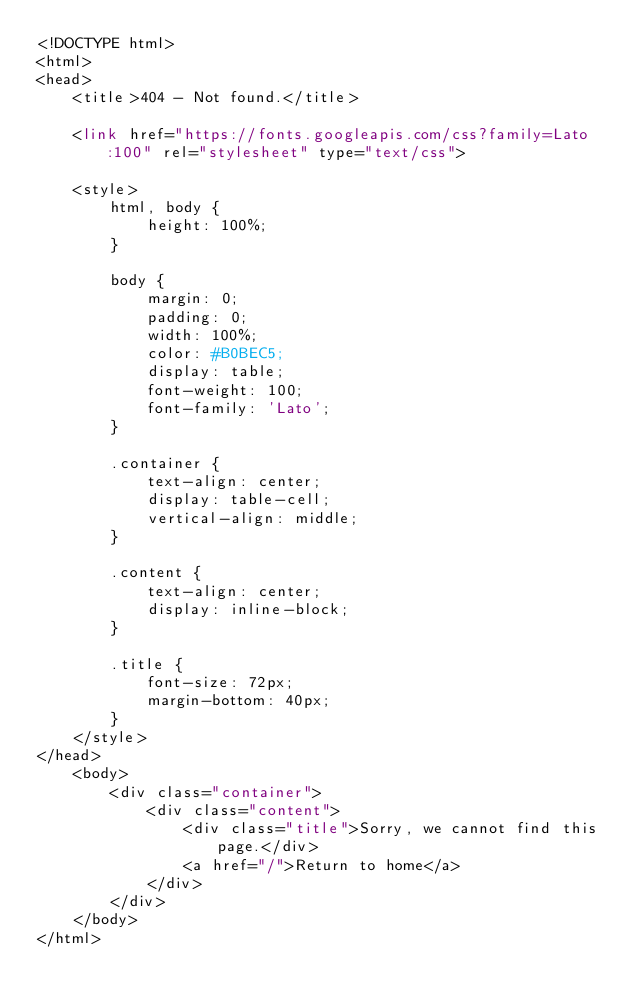Convert code to text. <code><loc_0><loc_0><loc_500><loc_500><_PHP_><!DOCTYPE html>
<html>
<head>
    <title>404 - Not found.</title>

    <link href="https://fonts.googleapis.com/css?family=Lato:100" rel="stylesheet" type="text/css">

    <style>
        html, body {
            height: 100%;
        }

        body {
            margin: 0;
            padding: 0;
            width: 100%;
            color: #B0BEC5;
            display: table;
            font-weight: 100;
            font-family: 'Lato';
        }

        .container {
            text-align: center;
            display: table-cell;
            vertical-align: middle;
        }

        .content {
            text-align: center;
            display: inline-block;
        }

        .title {
            font-size: 72px;
            margin-bottom: 40px;
        }
    </style>
</head>
    <body>
        <div class="container">
            <div class="content">
                <div class="title">Sorry, we cannot find this page.</div>
                <a href="/">Return to home</a>
            </div>
        </div>
    </body>
</html>
</code> 